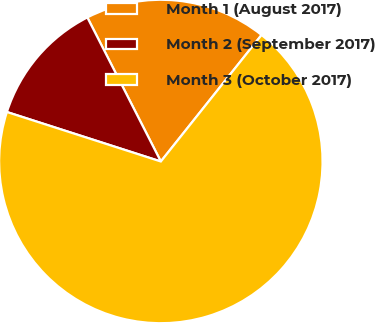Convert chart to OTSL. <chart><loc_0><loc_0><loc_500><loc_500><pie_chart><fcel>Month 1 (August 2017)<fcel>Month 2 (September 2017)<fcel>Month 3 (October 2017)<nl><fcel>18.21%<fcel>12.54%<fcel>69.25%<nl></chart> 